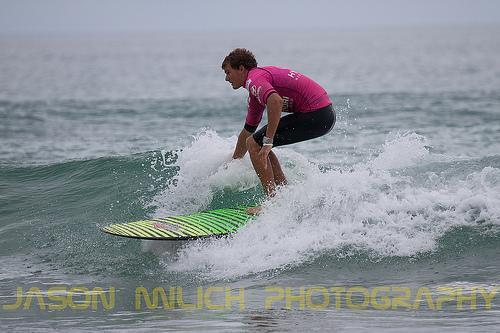How many surfers are there?
Give a very brief answer. 1. 